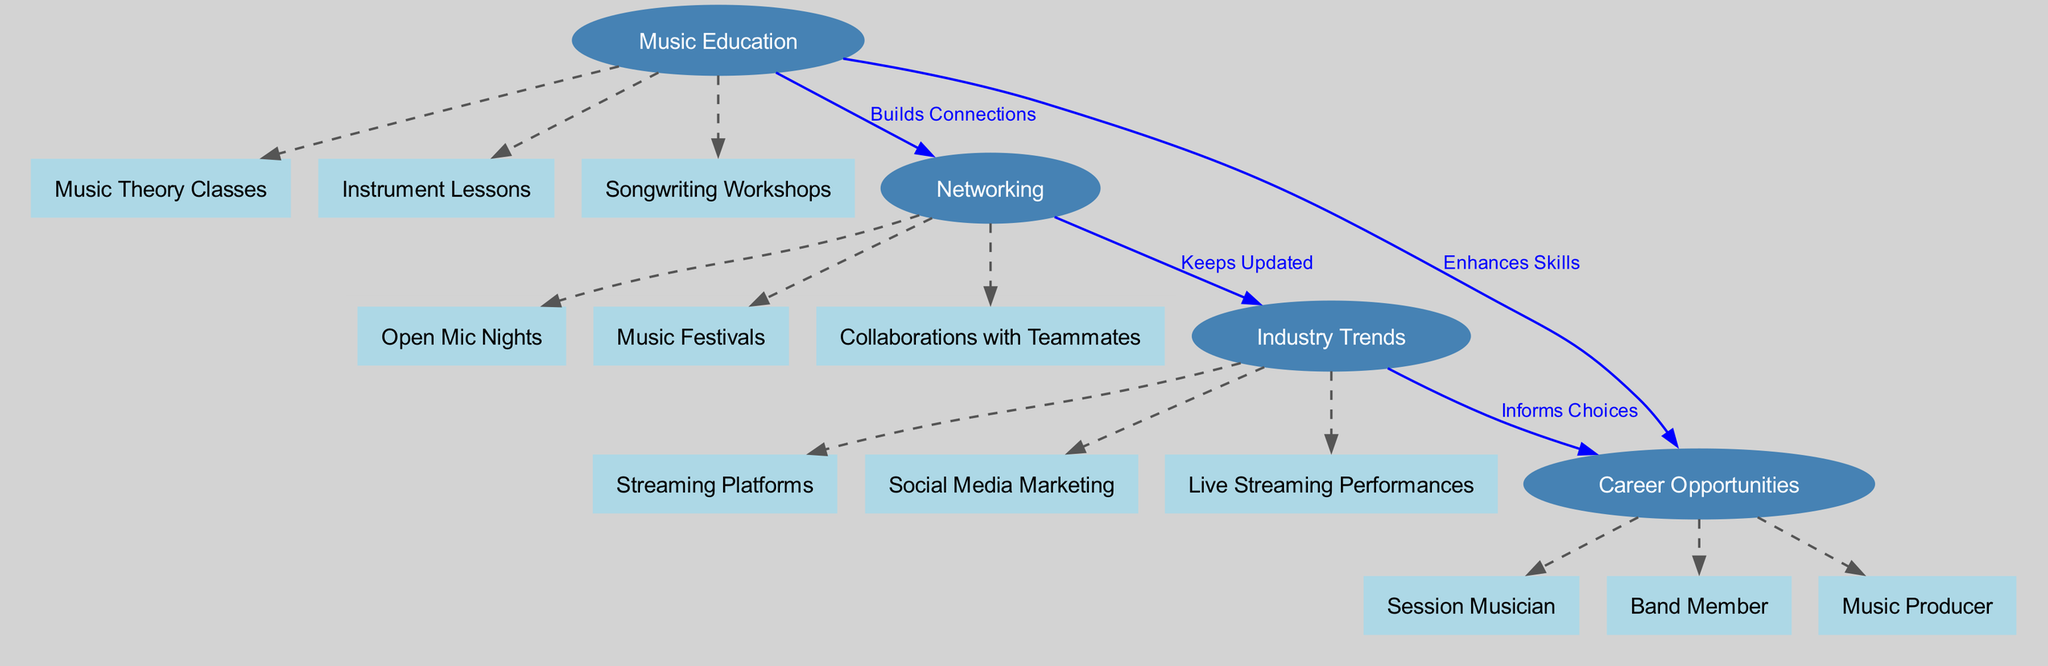What are the main categories in the diagram? The diagram's main categories are Music Education, Networking, Industry Trends, and Career Opportunities. Each category is represented as a node in the diagram, showing the broad areas of focus for aspiring musicians.
Answer: Music Education, Networking, Industry Trends, Career Opportunities How many child nodes does Music Education have? Music Education has three child nodes: Music Theory Classes, Instrument Lessons, and Songwriting Workshops. Counting these provides the answer.
Answer: 3 What relationship exists between Networking and Industry Trends? The edge between Networking and Industry Trends is labeled "Keeps Updated," which means that networking plays a role in staying informed about industry trends.
Answer: Keeps Updated Which career opportunity is linked directly to industry trends? The edge that connects Industry Trends to Career Opportunities indicates that choices in career opportunities are informed by trends. Session Musician, Band Member, and Music Producer are all potentials.
Answer: Session Musician, Band Member, Music Producer How does Music Education enhance skills? The diagram shows a direct edge from Music Education to Career Opportunities labeled "Enhances Skills." This means that education improves the skills needed for various music careers.
Answer: Enhances Skills What types of events are part of Networking? The child nodes of Networking include Open Mic Nights, Music Festivals, and Collaborations with Teammates. These are specific networking opportunities designed for musicians to connect and grow.
Answer: Open Mic Nights, Music Festivals, Collaborations with Teammates How do industry trends inform career choices? The diagram illustrates a flow from Industry Trends to Career Opportunities with the label "Informs Choices." This indicates that understanding trends in the music industry influences decisions about career paths.
Answer: Informs Choices Which aspects of career opportunities are not directly related to Music Education? While Music Education is connected to Career Opportunities through skills enhancement, specific career types like Music Producer, Session Musician, and Band Member do not have an educational origin highlighted in the diagram. Therefore, they are implicitly connected but not directly originating from Music Education.
Answer: Music Producer, Session Musician, Band Member 